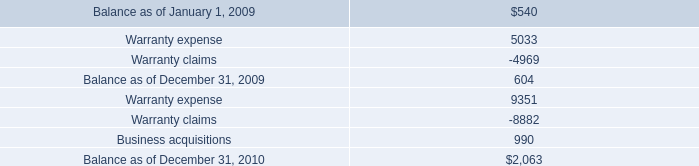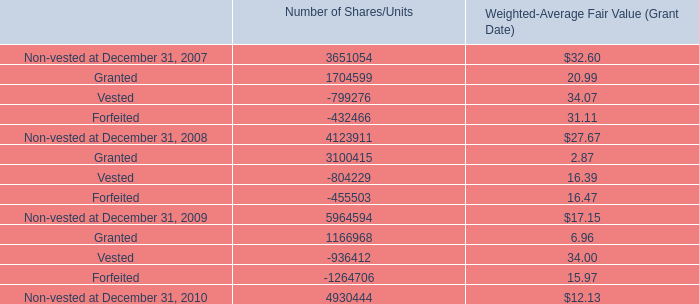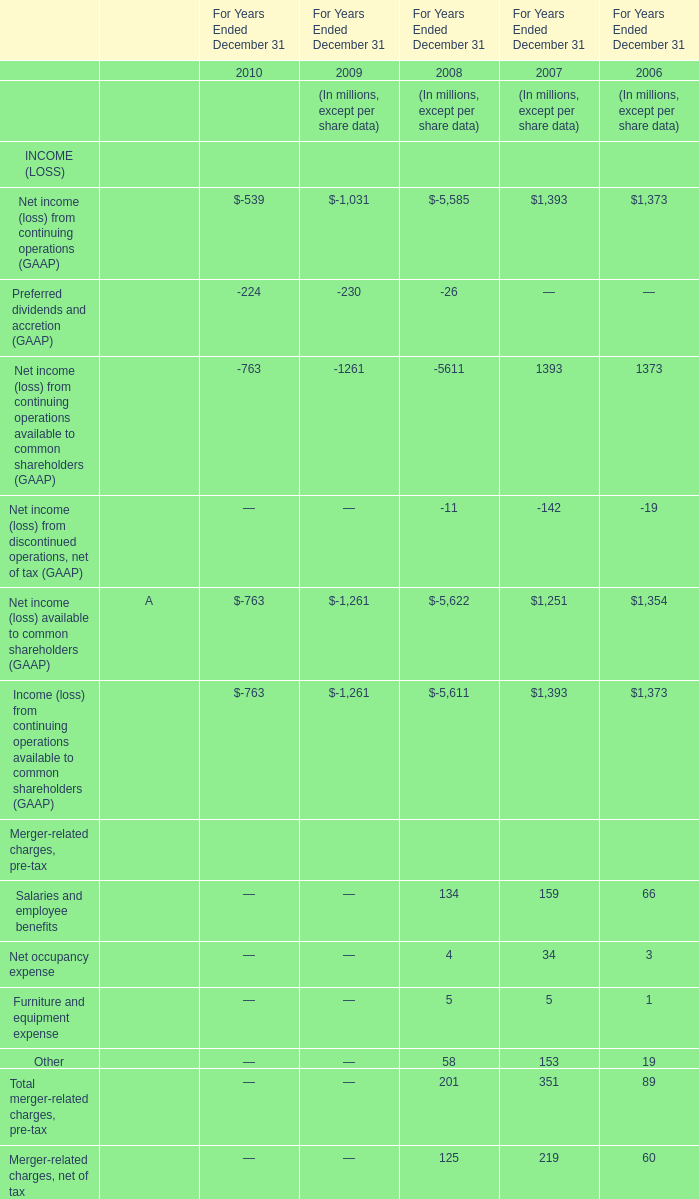What's the increasing rate of Total merger-related charges, pre-tax in 2007? 
Computations: ((351 - 89) / 89)
Answer: 2.94382. 